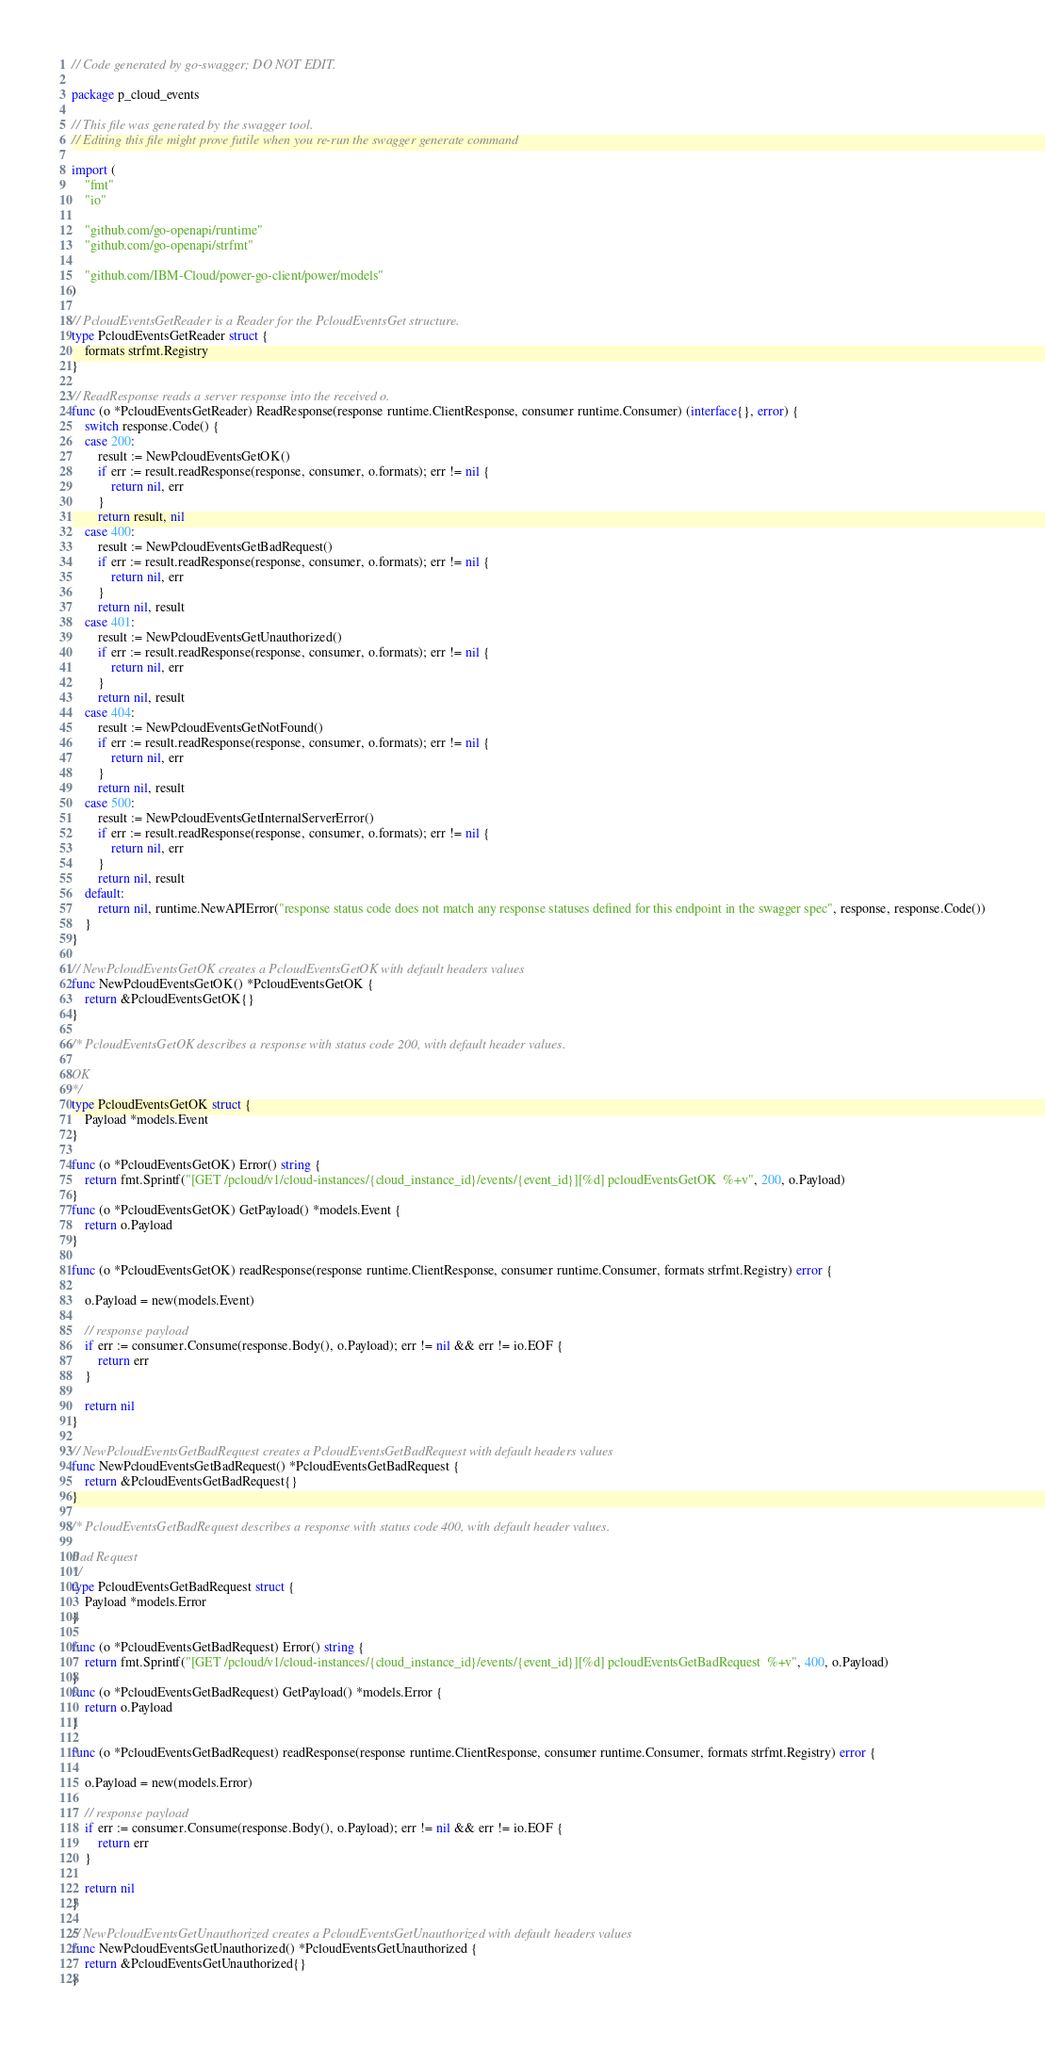<code> <loc_0><loc_0><loc_500><loc_500><_Go_>// Code generated by go-swagger; DO NOT EDIT.

package p_cloud_events

// This file was generated by the swagger tool.
// Editing this file might prove futile when you re-run the swagger generate command

import (
	"fmt"
	"io"

	"github.com/go-openapi/runtime"
	"github.com/go-openapi/strfmt"

	"github.com/IBM-Cloud/power-go-client/power/models"
)

// PcloudEventsGetReader is a Reader for the PcloudEventsGet structure.
type PcloudEventsGetReader struct {
	formats strfmt.Registry
}

// ReadResponse reads a server response into the received o.
func (o *PcloudEventsGetReader) ReadResponse(response runtime.ClientResponse, consumer runtime.Consumer) (interface{}, error) {
	switch response.Code() {
	case 200:
		result := NewPcloudEventsGetOK()
		if err := result.readResponse(response, consumer, o.formats); err != nil {
			return nil, err
		}
		return result, nil
	case 400:
		result := NewPcloudEventsGetBadRequest()
		if err := result.readResponse(response, consumer, o.formats); err != nil {
			return nil, err
		}
		return nil, result
	case 401:
		result := NewPcloudEventsGetUnauthorized()
		if err := result.readResponse(response, consumer, o.formats); err != nil {
			return nil, err
		}
		return nil, result
	case 404:
		result := NewPcloudEventsGetNotFound()
		if err := result.readResponse(response, consumer, o.formats); err != nil {
			return nil, err
		}
		return nil, result
	case 500:
		result := NewPcloudEventsGetInternalServerError()
		if err := result.readResponse(response, consumer, o.formats); err != nil {
			return nil, err
		}
		return nil, result
	default:
		return nil, runtime.NewAPIError("response status code does not match any response statuses defined for this endpoint in the swagger spec", response, response.Code())
	}
}

// NewPcloudEventsGetOK creates a PcloudEventsGetOK with default headers values
func NewPcloudEventsGetOK() *PcloudEventsGetOK {
	return &PcloudEventsGetOK{}
}

/* PcloudEventsGetOK describes a response with status code 200, with default header values.

OK
*/
type PcloudEventsGetOK struct {
	Payload *models.Event
}

func (o *PcloudEventsGetOK) Error() string {
	return fmt.Sprintf("[GET /pcloud/v1/cloud-instances/{cloud_instance_id}/events/{event_id}][%d] pcloudEventsGetOK  %+v", 200, o.Payload)
}
func (o *PcloudEventsGetOK) GetPayload() *models.Event {
	return o.Payload
}

func (o *PcloudEventsGetOK) readResponse(response runtime.ClientResponse, consumer runtime.Consumer, formats strfmt.Registry) error {

	o.Payload = new(models.Event)

	// response payload
	if err := consumer.Consume(response.Body(), o.Payload); err != nil && err != io.EOF {
		return err
	}

	return nil
}

// NewPcloudEventsGetBadRequest creates a PcloudEventsGetBadRequest with default headers values
func NewPcloudEventsGetBadRequest() *PcloudEventsGetBadRequest {
	return &PcloudEventsGetBadRequest{}
}

/* PcloudEventsGetBadRequest describes a response with status code 400, with default header values.

Bad Request
*/
type PcloudEventsGetBadRequest struct {
	Payload *models.Error
}

func (o *PcloudEventsGetBadRequest) Error() string {
	return fmt.Sprintf("[GET /pcloud/v1/cloud-instances/{cloud_instance_id}/events/{event_id}][%d] pcloudEventsGetBadRequest  %+v", 400, o.Payload)
}
func (o *PcloudEventsGetBadRequest) GetPayload() *models.Error {
	return o.Payload
}

func (o *PcloudEventsGetBadRequest) readResponse(response runtime.ClientResponse, consumer runtime.Consumer, formats strfmt.Registry) error {

	o.Payload = new(models.Error)

	// response payload
	if err := consumer.Consume(response.Body(), o.Payload); err != nil && err != io.EOF {
		return err
	}

	return nil
}

// NewPcloudEventsGetUnauthorized creates a PcloudEventsGetUnauthorized with default headers values
func NewPcloudEventsGetUnauthorized() *PcloudEventsGetUnauthorized {
	return &PcloudEventsGetUnauthorized{}
}
</code> 